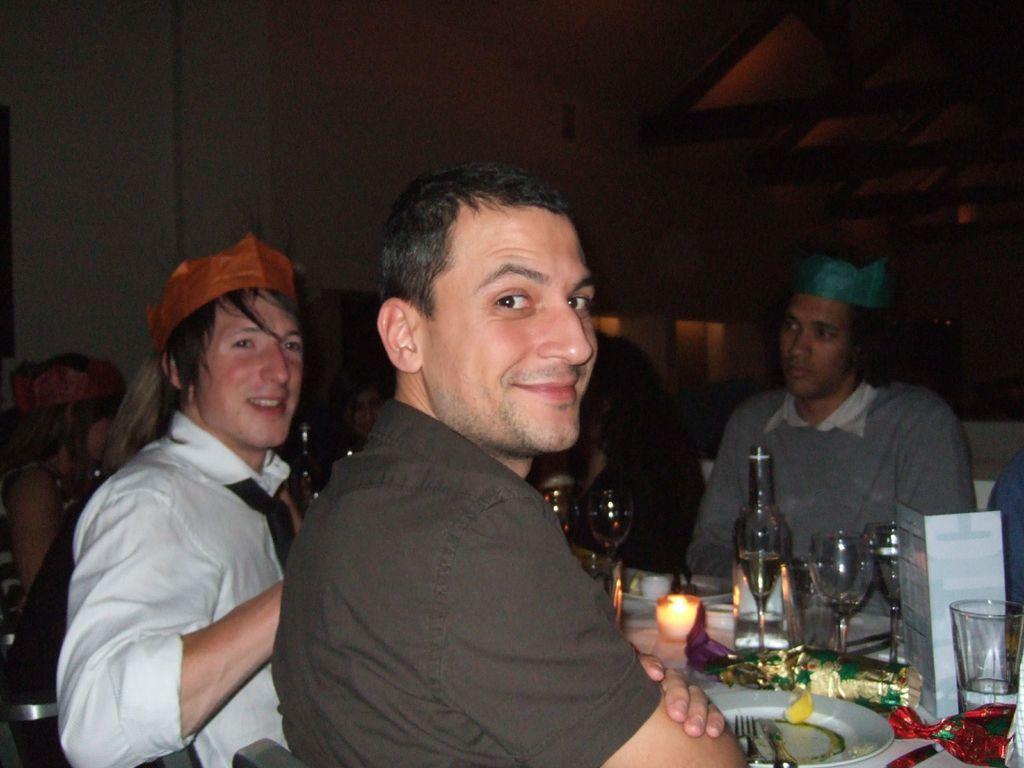Describe this image in one or two sentences. In this image we can see a group of people sitting on the chairs beside a table containing some plates, fork, knife, a bottle, a paper, wrappers and some glasses on it. On the backside we can see a wall. 